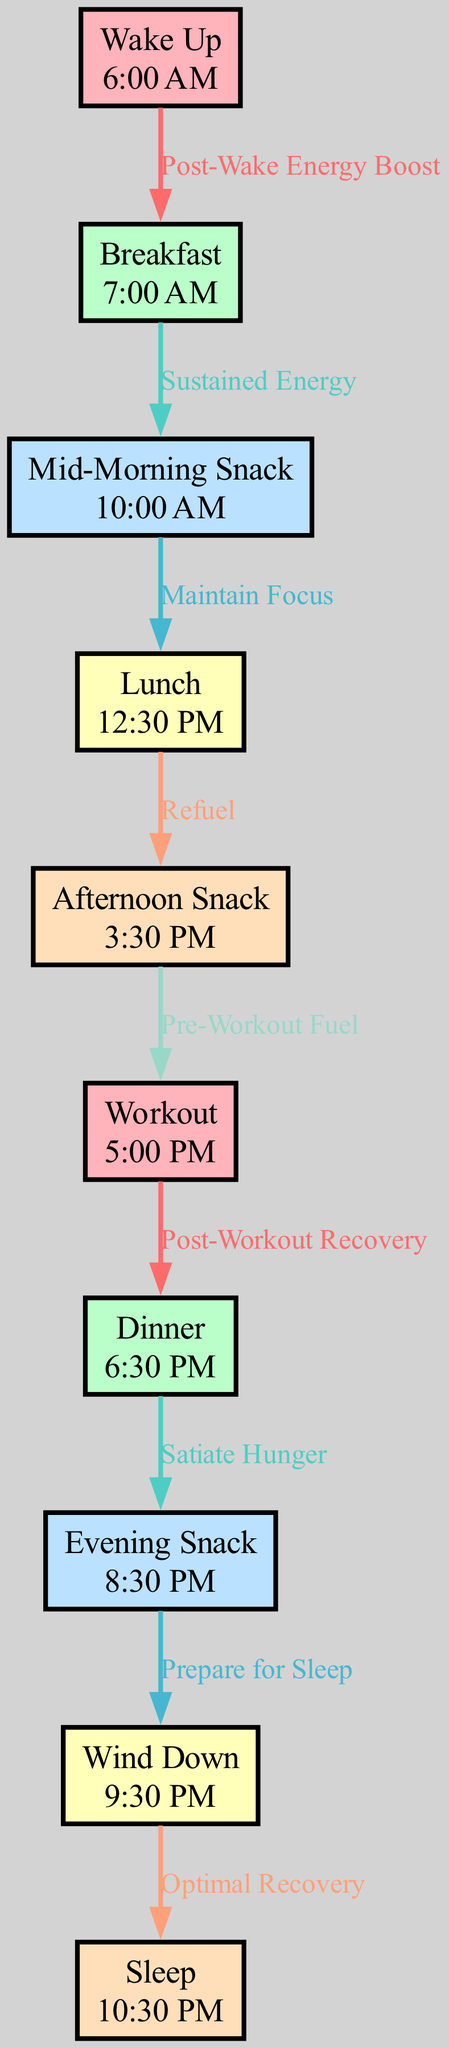What time is breakfast scheduled in the diagram? The diagram indicates that breakfast is scheduled at 7:00 AM, as each node includes a label and a corresponding time.
Answer: 7:00 AM How many nodes are in the daily routine diagram? By counting the number of distinct activities or events represented, there are 10 nodes listed in the data.
Answer: 10 What is the relationship between "Workout" and "Dinner"? The edge connecting "Workout" to "Dinner" indicates that dinner serves as a post-workout recovery meal, signifying it’s important to refuel after exercise.
Answer: Post-Workout Recovery What time do you have an afternoon snack? The diagram states that the afternoon snack is scheduled for 3:30 PM, which is clearly noted next to the corresponding node.
Answer: 3:30 PM Which activity follows "Wind Down"? According to the diagram's flow, the activity that follows "Wind Down" is "Sleep," as indicated by the directed edge connecting the two nodes.
Answer: Sleep What is the time difference between "Wake Up" and "Lunch"? The time of wake-up is 6:00 AM, and lunch is at 12:30 PM. To find the difference, calculate the hours from 6:00 AM to 12:30 PM, resulting in a total of 6 hours and 30 minutes.
Answer: 6 hours 30 minutes What is the significance of the edge labeled "Prepare for Sleep"? This edge connects "Evening Snack" to "Wind Down" and indicates that having a snack before winding down prepares the body for sleep, showing the importance of a nightly routine.
Answer: Prepare for Sleep Which two activities emphasize fueling for the workout? The activities that emphasize fueling the body for the workout are "Afternoon Snack" and "Workout," where the afternoon snack is designated as pre-workout fuel.
Answer: Afternoon Snack and Workout What activity precedes "Wind Down"? From the flow of the diagram, the activity that directly precedes "Wind Down" is "Evening Snack," which plays a role in preparing for sleep.
Answer: Evening Snack 